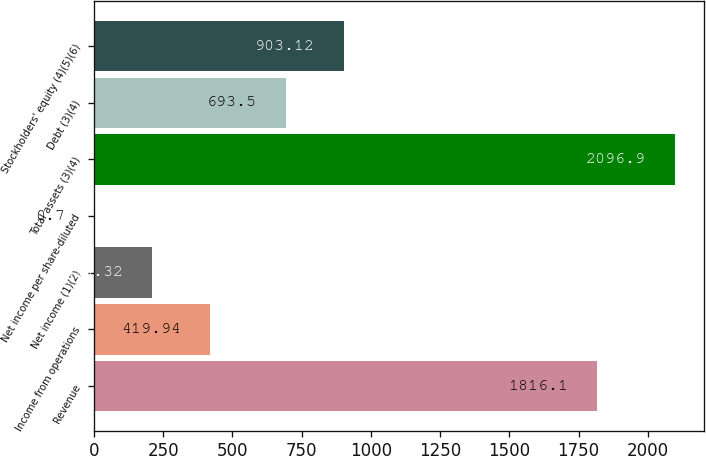<chart> <loc_0><loc_0><loc_500><loc_500><bar_chart><fcel>Revenue<fcel>Income from operations<fcel>Net income (1)(2)<fcel>Net income per share-diluted<fcel>Total assets (3)(4)<fcel>Debt (3)(4)<fcel>Stockholders' equity (4)(5)(6)<nl><fcel>1816.1<fcel>419.94<fcel>210.32<fcel>0.7<fcel>2096.9<fcel>693.5<fcel>903.12<nl></chart> 